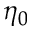<formula> <loc_0><loc_0><loc_500><loc_500>\eta _ { 0 }</formula> 